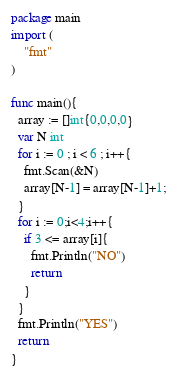Convert code to text. <code><loc_0><loc_0><loc_500><loc_500><_Go_>package main
import (
    "fmt"
)

func main(){
  array := []int{0,0,0,0}
  var N int
  for i := 0 ; i < 6 ; i++{
    fmt.Scan(&N)
    array[N-1] = array[N-1]+1;
  }
  for i := 0;i<4;i++{
    if 3 <= array[i]{
      fmt.Println("NO")
      return
    }
  }
  fmt.Println("YES")
  return
}
</code> 